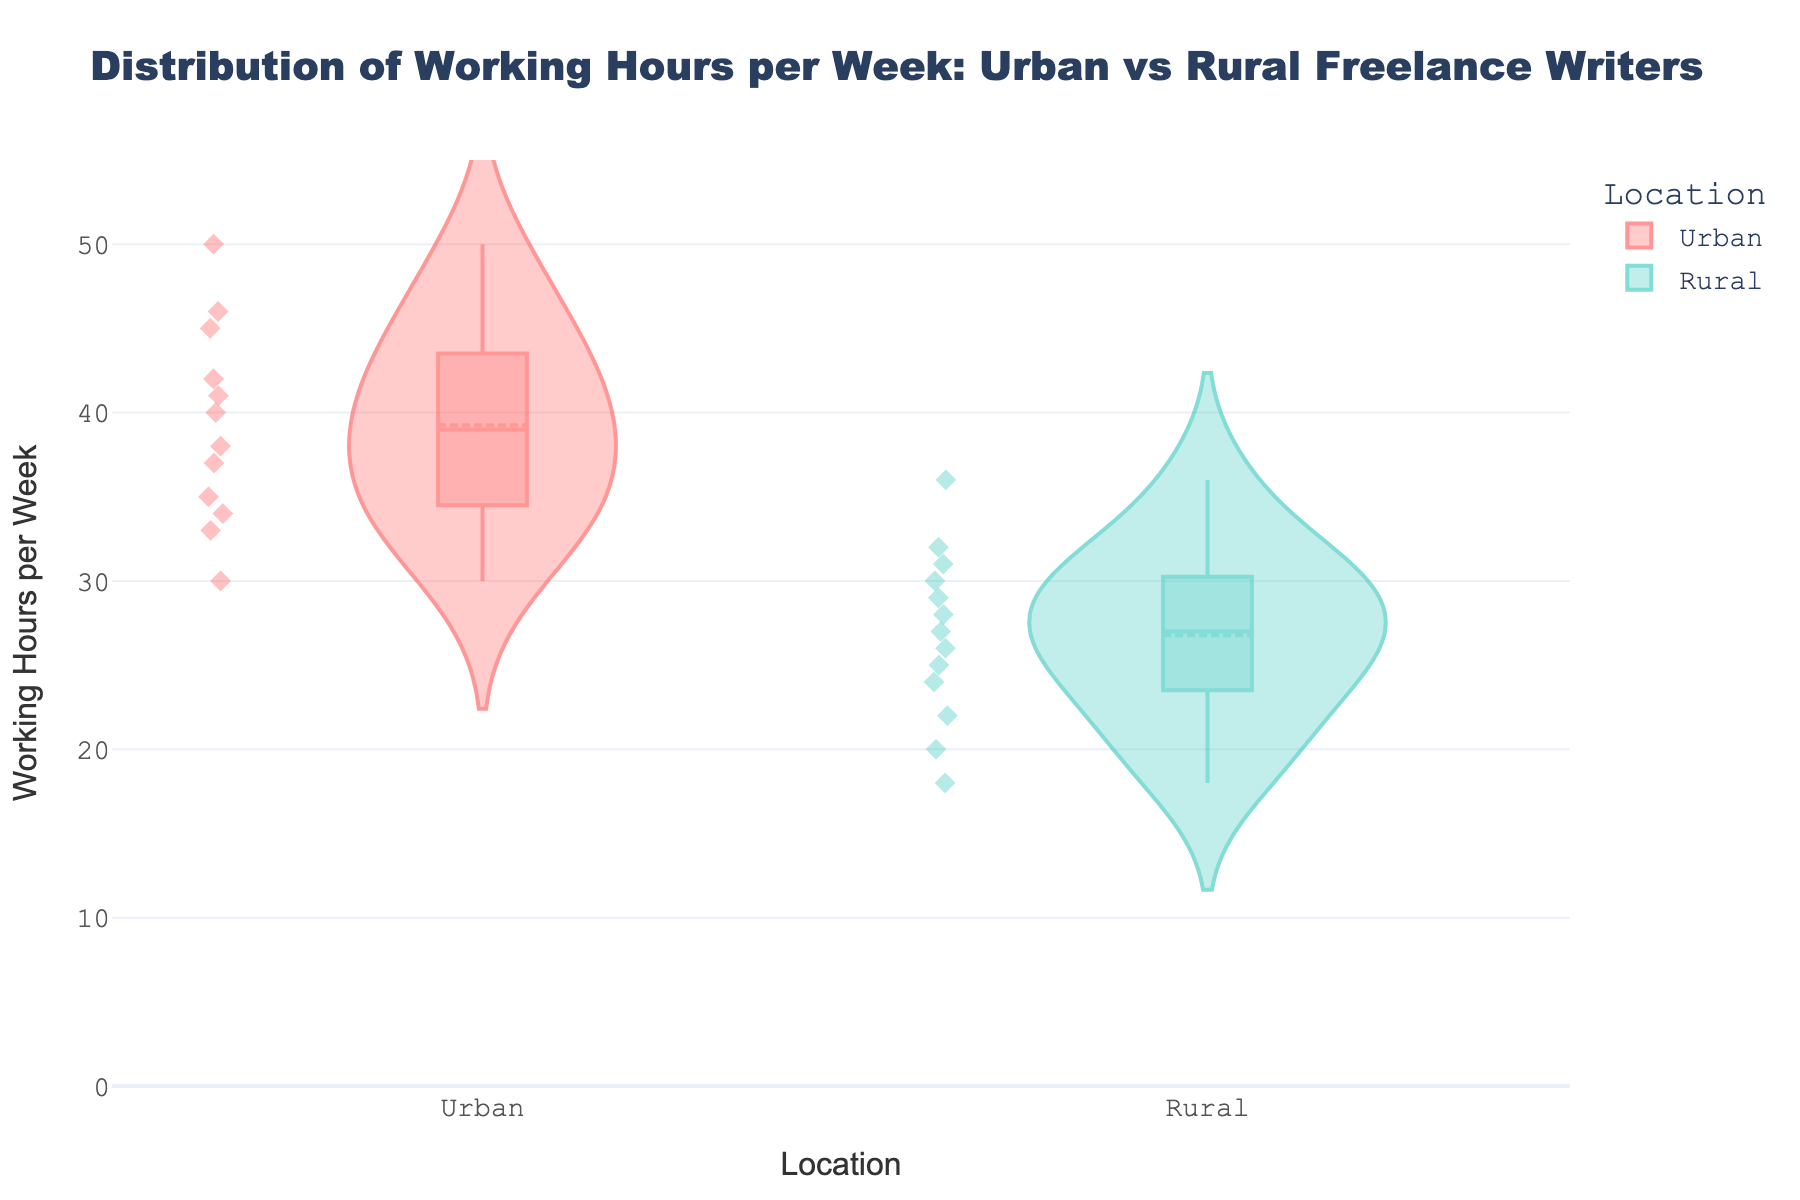What is the title of the violin plot? The title is generally found at the top of the chart, prominently displayed in larger or bold font. In this case, it reads: "Distribution of Working Hours per Week: Urban vs Rural Freelance Writers."
Answer: Distribution of Working Hours per Week: Urban vs Rural Freelance Writers What are the labels for the x-axis and y-axis? The x-axis label is "Location," which indicates whether the data points are from Urban or Rural areas. The y-axis label is "Working Hours per Week," representing the number of hours worked per week by the freelancers.
Answer: Location; Working Hours per Week How many freelance writers are represented in the 'Urban' category? To find the number of data points in the Urban category, count the individual points within the violin shaped distribution for Urban. According to the data, there are 12 points.
Answer: 12 What is the range of working hours per week for rural freelance writers? To determine the range, look at the lowest and highest data points within the Rural violin plot. The lowest is 18 hours, and the highest is 36 hours. Hence, the range is 36 - 18 = 18 hours.
Answer: 18 hours Which category, Urban or Rural, has a higher median working hours per week? The median is usually indicated by a horizontal line within the boxplot inside each violin. By comparing them, you can see that the Urban category has a higher median compared to the Rural category.
Answer: Urban What is the interquartile range (IQR) for Urban freelance writers? The IQR is the difference between the third quartile (Q3) and the first quartile (Q1). From the boxplot in the Urban violin, estimate Q3 and Q1 values (typically, the upper and lower edges of the box). In this case, Q3 is around 45 and Q1 is around 35. IQR = 45 - 35 = 10 hours.
Answer: 10 hours Are there any outliers in either category? Outliers in a violin plot are often displayed as individual points separated from the rest of the data. By inspecting the plot, you can check for these separated points outside the whiskers of the boxplot. There are no outliers in either the Urban or Rural categories.
Answer: No Which category shows more variability in working hours? Variability can be assessed by the spread of the data within the violin. A wider or more spread-out violin indicates higher variability. Urban clearly shows a broader spread compared to Rural, indicating more variability.
Answer: Urban What is the mean working hours per week for rural freelance writers? The mean line is usually present in the violin plot. For the Rural category, locate this line, which appears at around 27 hours per week.
Answer: Approximately 27 hours 